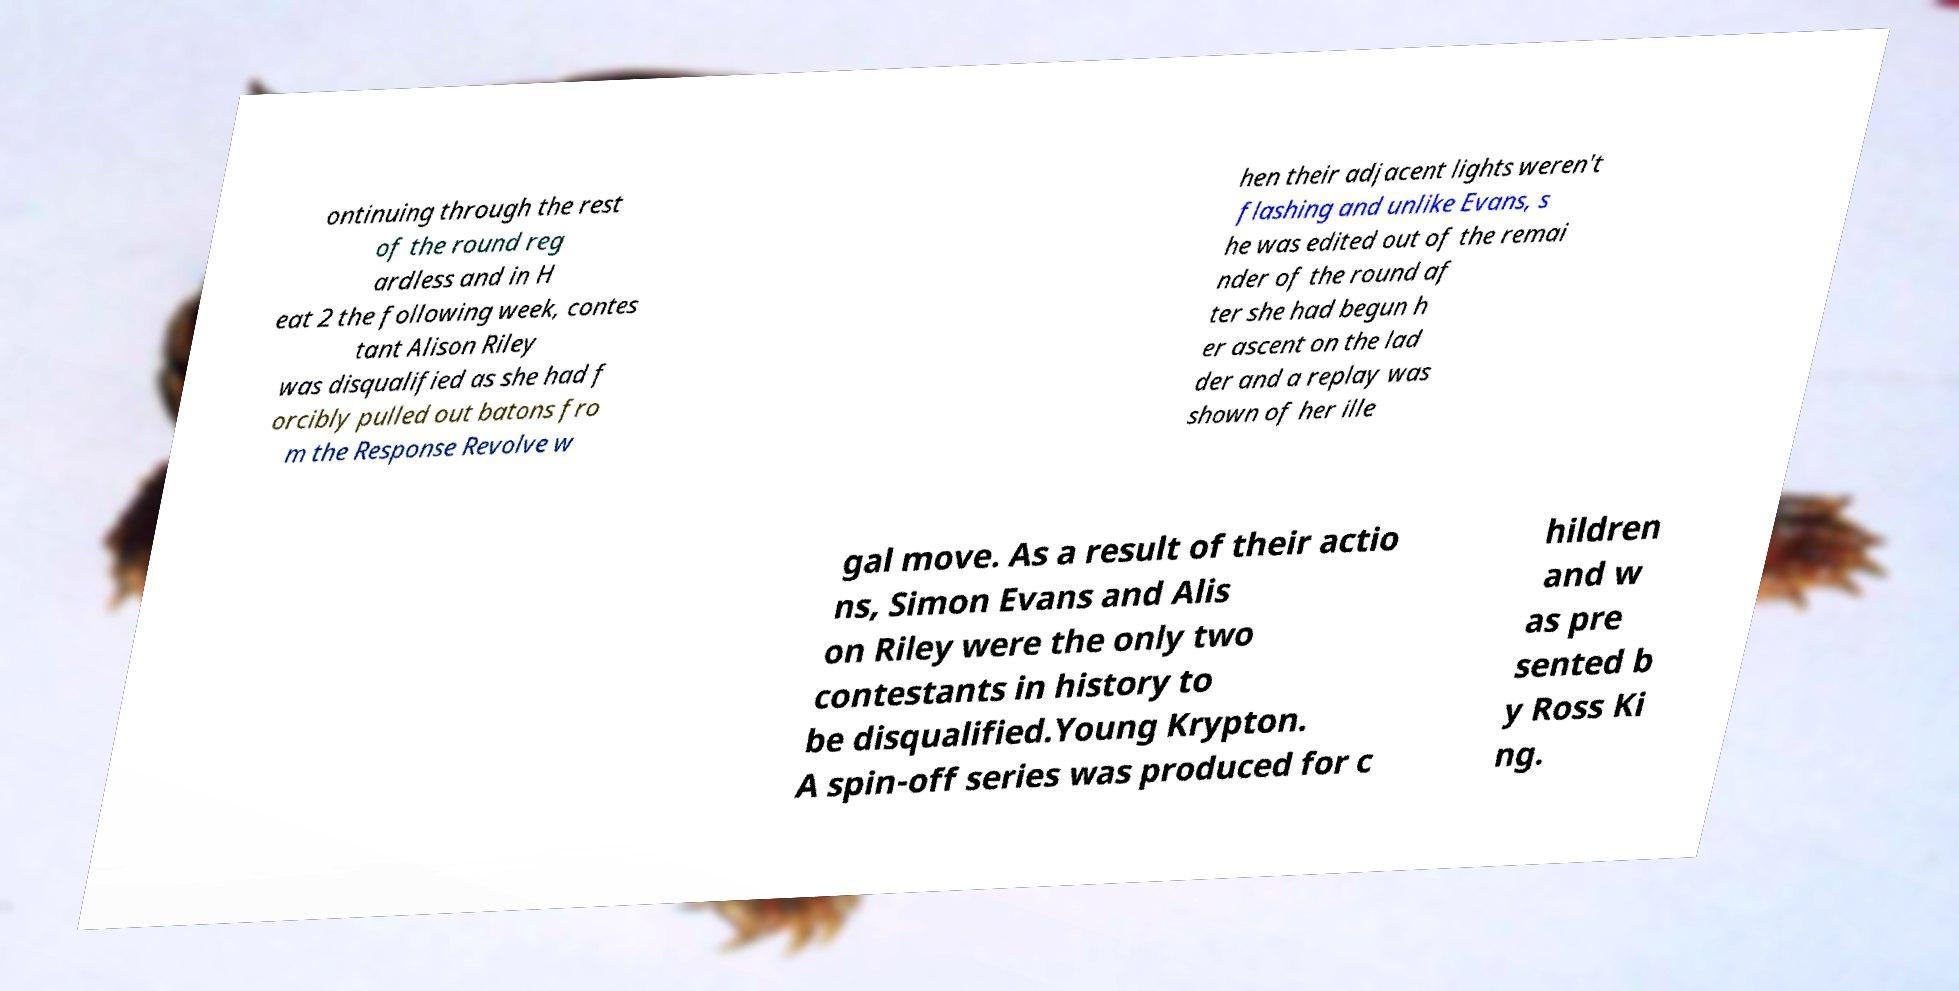Can you read and provide the text displayed in the image?This photo seems to have some interesting text. Can you extract and type it out for me? ontinuing through the rest of the round reg ardless and in H eat 2 the following week, contes tant Alison Riley was disqualified as she had f orcibly pulled out batons fro m the Response Revolve w hen their adjacent lights weren't flashing and unlike Evans, s he was edited out of the remai nder of the round af ter she had begun h er ascent on the lad der and a replay was shown of her ille gal move. As a result of their actio ns, Simon Evans and Alis on Riley were the only two contestants in history to be disqualified.Young Krypton. A spin-off series was produced for c hildren and w as pre sented b y Ross Ki ng. 